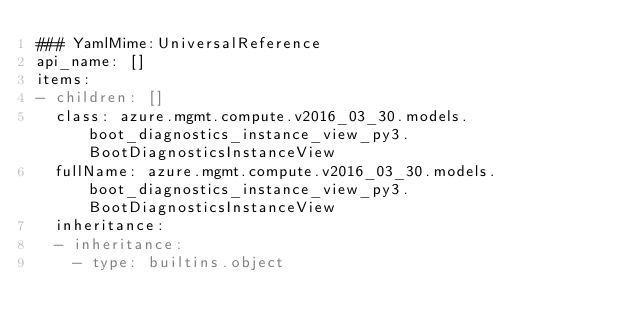Convert code to text. <code><loc_0><loc_0><loc_500><loc_500><_YAML_>### YamlMime:UniversalReference
api_name: []
items:
- children: []
  class: azure.mgmt.compute.v2016_03_30.models.boot_diagnostics_instance_view_py3.BootDiagnosticsInstanceView
  fullName: azure.mgmt.compute.v2016_03_30.models.boot_diagnostics_instance_view_py3.BootDiagnosticsInstanceView
  inheritance:
  - inheritance:
    - type: builtins.object</code> 